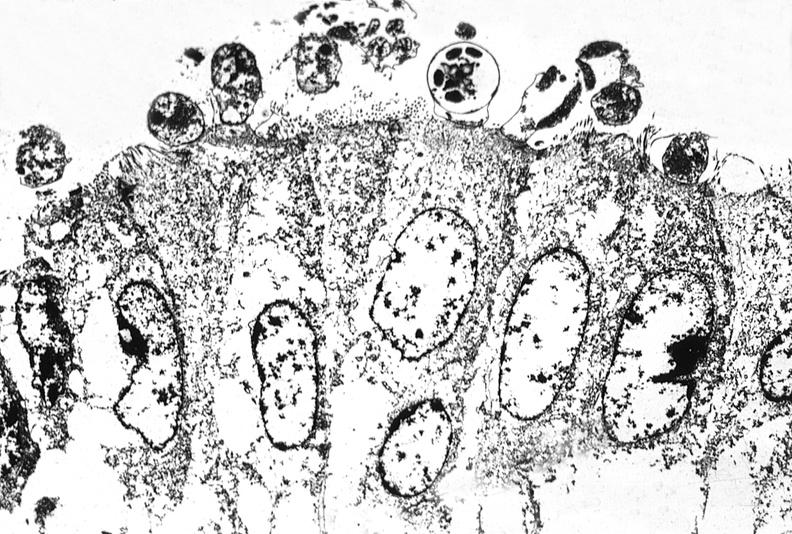does serous cyst show colon biopsy, cryptosporidia?
Answer the question using a single word or phrase. No 